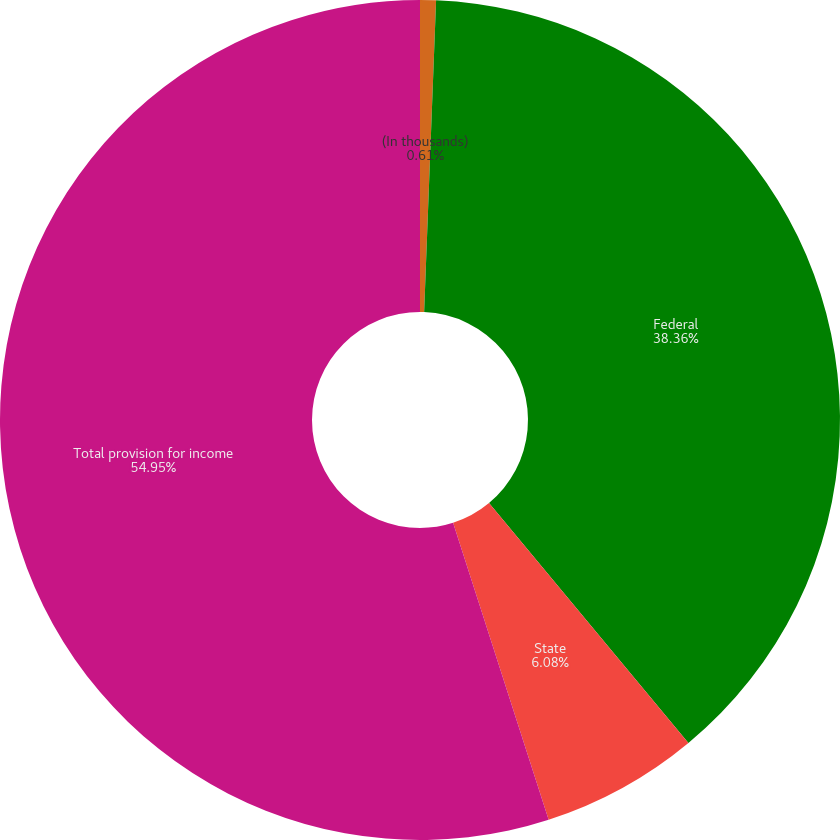<chart> <loc_0><loc_0><loc_500><loc_500><pie_chart><fcel>(In thousands)<fcel>Federal<fcel>State<fcel>Total provision for income<nl><fcel>0.61%<fcel>38.36%<fcel>6.08%<fcel>54.96%<nl></chart> 